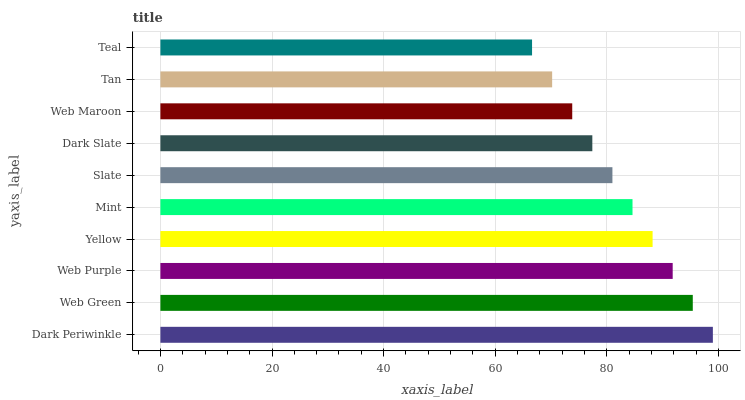Is Teal the minimum?
Answer yes or no. Yes. Is Dark Periwinkle the maximum?
Answer yes or no. Yes. Is Web Green the minimum?
Answer yes or no. No. Is Web Green the maximum?
Answer yes or no. No. Is Dark Periwinkle greater than Web Green?
Answer yes or no. Yes. Is Web Green less than Dark Periwinkle?
Answer yes or no. Yes. Is Web Green greater than Dark Periwinkle?
Answer yes or no. No. Is Dark Periwinkle less than Web Green?
Answer yes or no. No. Is Mint the high median?
Answer yes or no. Yes. Is Slate the low median?
Answer yes or no. Yes. Is Slate the high median?
Answer yes or no. No. Is Web Maroon the low median?
Answer yes or no. No. 